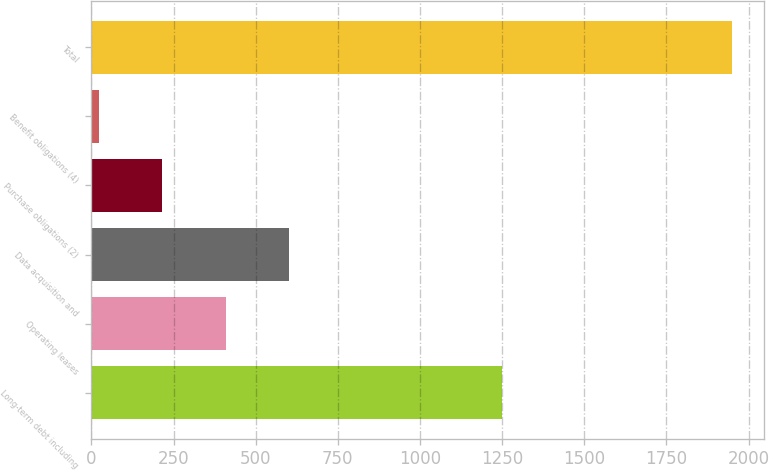Convert chart to OTSL. <chart><loc_0><loc_0><loc_500><loc_500><bar_chart><fcel>Long-term debt including<fcel>Operating leases<fcel>Data acquisition and<fcel>Purchase obligations (2)<fcel>Benefit obligations (4)<fcel>Total<nl><fcel>1251<fcel>408.4<fcel>601.1<fcel>215.7<fcel>23<fcel>1950<nl></chart> 